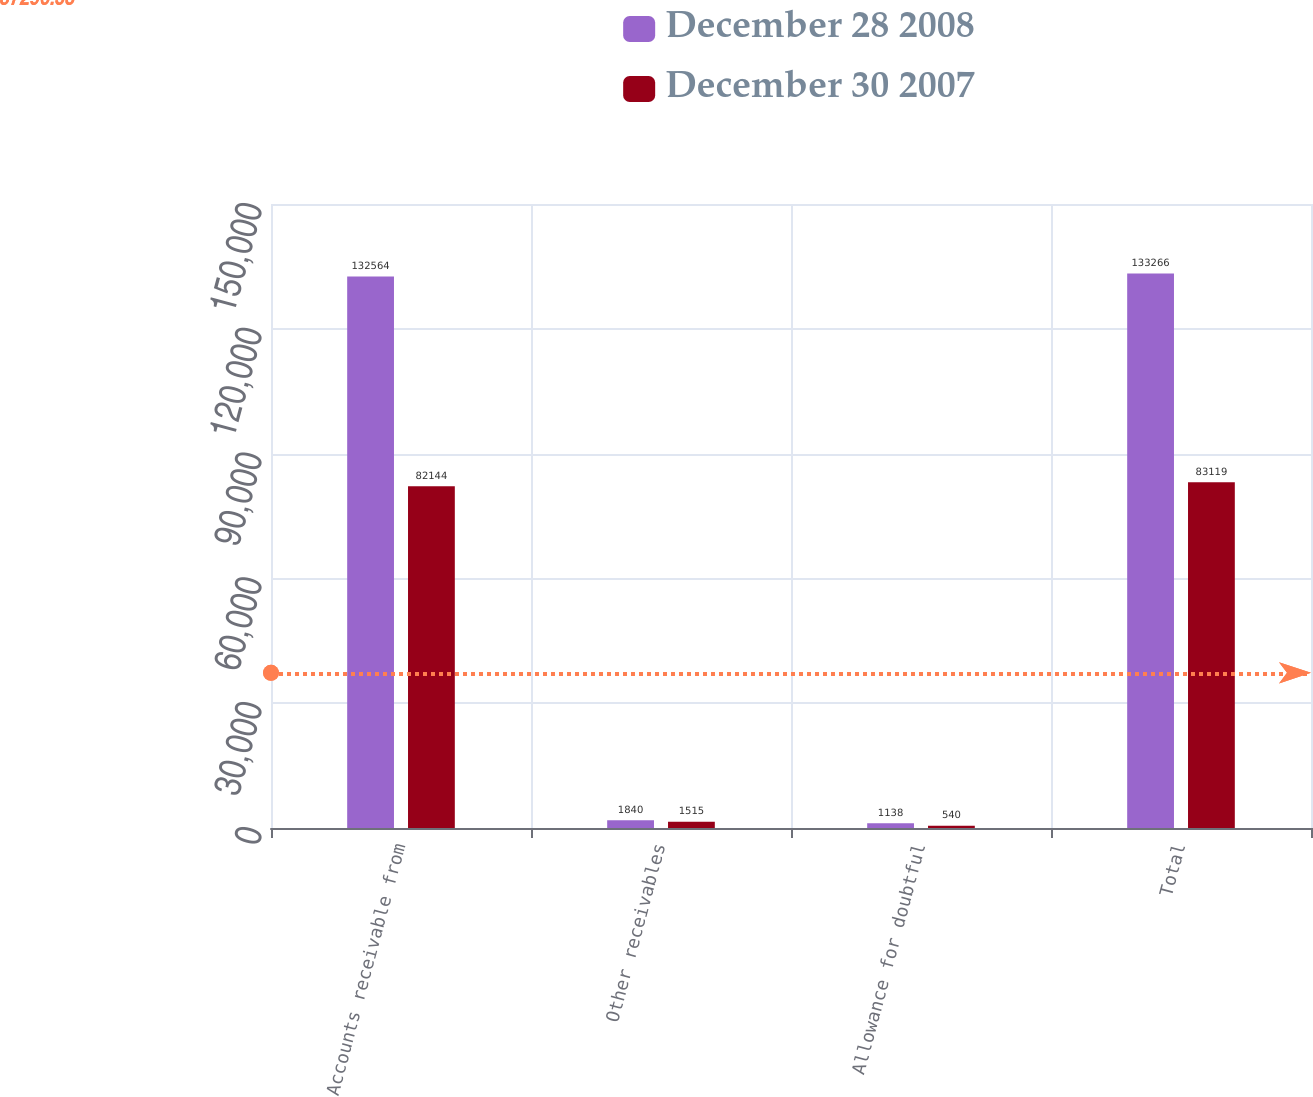Convert chart to OTSL. <chart><loc_0><loc_0><loc_500><loc_500><stacked_bar_chart><ecel><fcel>Accounts receivable from<fcel>Other receivables<fcel>Allowance for doubtful<fcel>Total<nl><fcel>December 28 2008<fcel>132564<fcel>1840<fcel>1138<fcel>133266<nl><fcel>December 30 2007<fcel>82144<fcel>1515<fcel>540<fcel>83119<nl></chart> 